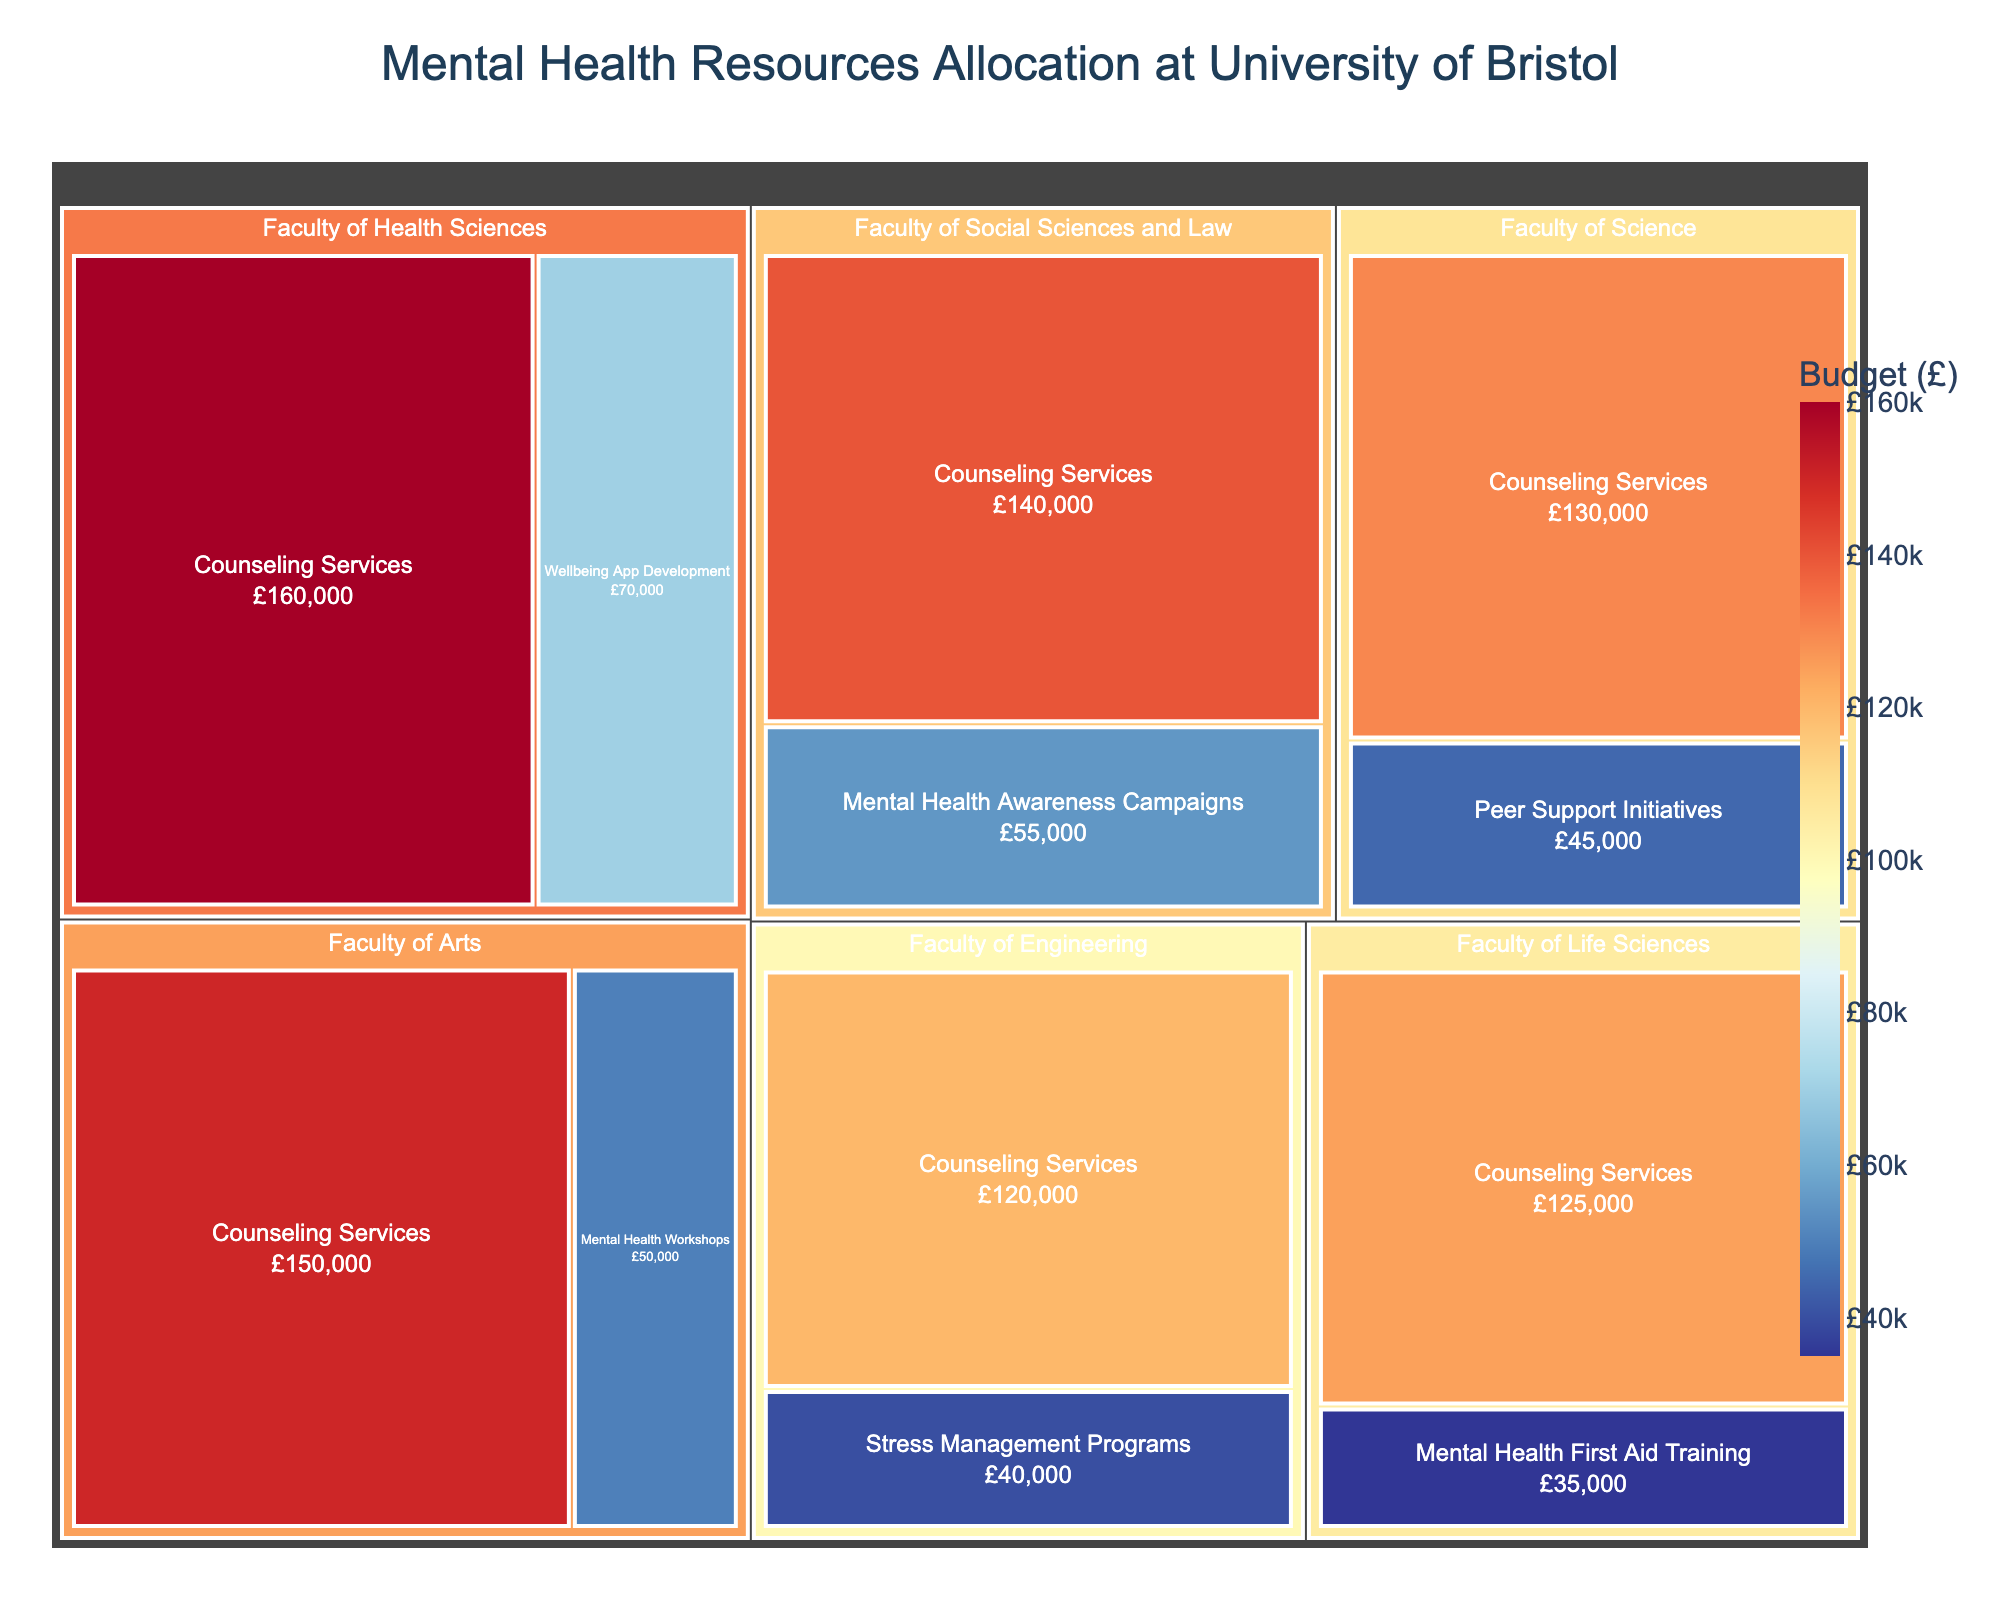What is the total budget allocated to the Faculty of Arts for mental health resources? Sum the budgets for Counseling Services and Mental Health Workshops in the Faculty of Arts: £150,000 + £50,000
Answer: £200,000 What category in the Faculty of Health Sciences has the highest budget allocation? Compare the budgets for Counseling Services and Wellbeing App Development in the Faculty of Health Sciences. Counseling Services has £160,000 and Wellbeing App Development has £70,000.
Answer: Counseling Services Which department has the largest budget allocated to Counseling Services? Compare the budget allocations for Counseling Services across all departments. The Faculty of Health Sciences has the highest at £160,000.
Answer: Faculty of Health Sciences What is the total budget allocated across all departments for Counseling Services? Sum the budgets for Counseling Services across all departments: £150,000 + £120,000 + £130,000 + £140,000 + £160,000 + £125,000
Answer: £825,000 How does the budget for Mental Health Awareness Campaigns in the Faculty of Social Sciences and Law compare to Mental Health First Aid Training in the Faculty of Life Sciences? Compare the budgets: Mental Health Awareness Campaigns has £55,000, and Mental Health First Aid Training has £35,000.
Answer: Mental Health Awareness Campaigns is higher What fraction of the total budget allocated to the Faculty of Life Sciences goes to Counseling Services? Sum the total budget for the Faculty of Life Sciences: £125,000 (Counseling Services) + £35,000 (Mental Health First Aid Training) = £160,000. Then, divide the Counseling Services budget by the total: £125,000 / £160,000 = 0.78125
Answer: 78.13% Which category in the Faculty of Engineering has the lower budget allocation? Compare the budgets for Counseling Services and Stress Management Programs in the Faculty of Engineering. Counseling Services has £120,000, and Stress Management Programs have £40,000.
Answer: Stress Management Programs What is the second highest single budget allocation across all categories and departments? List all budget allocations and find the second highest value. The budgets are: (£150,000, £50,000, £120,000, £40,000, £130,000, £45,000, £140,000, £55,000, £160,000, £70,000, £125,000, £35,000). The highest is £160,000, and the second highest is £150,000.
Answer: £150,000 Which department dedicates comparatively more budget to multiple categories than just Counseling Services? Compare the total budget for multiple categories versus just Counseling Services in each department. The Faculty of Health Sciences has both £160,000 for Counseling Services and £70,000 for Wellbeing App Development, which is significant. Other departments have less or similar proportions.
Answer: Faculty of Health Sciences How does the budget allocation for peer support initiatives in the Faculty of Science compare to mental health workshops in the Faculty of Arts? Compare the budgets: Peer Support Initiatives in Faculty of Science has £45,000, while Mental Health Workshops in Faculty of Arts has £50,000.
Answer: Mental Health Workshops in Faculty of Arts is higher 